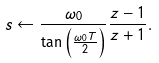Convert formula to latex. <formula><loc_0><loc_0><loc_500><loc_500>s \leftarrow { \frac { \omega _ { 0 } } { \tan \left ( { \frac { \omega _ { 0 } T } { 2 } } \right ) } } { \frac { z - 1 } { z + 1 } } .</formula> 